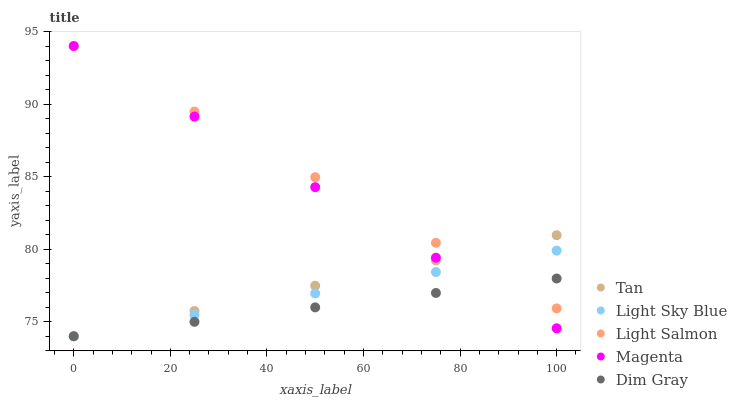Does Dim Gray have the minimum area under the curve?
Answer yes or no. Yes. Does Light Salmon have the maximum area under the curve?
Answer yes or no. Yes. Does Tan have the minimum area under the curve?
Answer yes or no. No. Does Tan have the maximum area under the curve?
Answer yes or no. No. Is Dim Gray the smoothest?
Answer yes or no. Yes. Is Light Salmon the roughest?
Answer yes or no. Yes. Is Light Sky Blue the smoothest?
Answer yes or no. No. Is Light Sky Blue the roughest?
Answer yes or no. No. Does Dim Gray have the lowest value?
Answer yes or no. Yes. Does Light Salmon have the lowest value?
Answer yes or no. No. Does Magenta have the highest value?
Answer yes or no. Yes. Does Tan have the highest value?
Answer yes or no. No. Does Dim Gray intersect Light Salmon?
Answer yes or no. Yes. Is Dim Gray less than Light Salmon?
Answer yes or no. No. Is Dim Gray greater than Light Salmon?
Answer yes or no. No. 